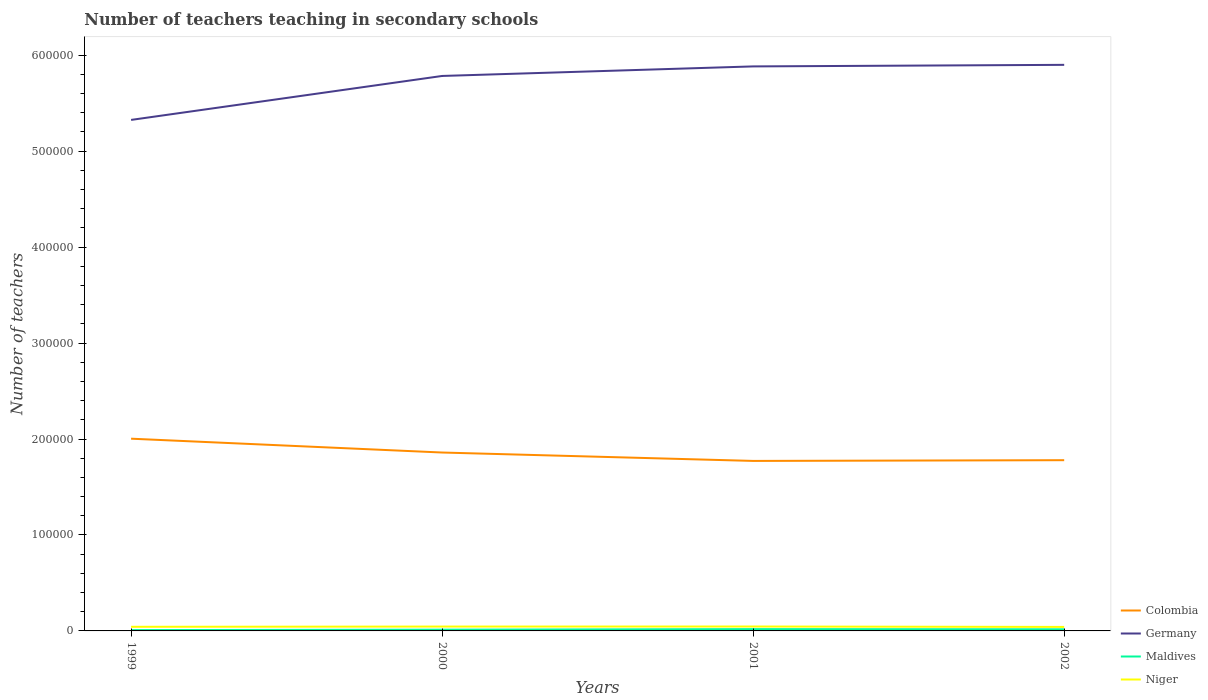Across all years, what is the maximum number of teachers teaching in secondary schools in Colombia?
Your answer should be compact. 1.77e+05. In which year was the number of teachers teaching in secondary schools in Germany maximum?
Keep it short and to the point. 1999. What is the total number of teachers teaching in secondary schools in Maldives in the graph?
Your response must be concise. -574. What is the difference between the highest and the second highest number of teachers teaching in secondary schools in Maldives?
Provide a short and direct response. 1010. What is the difference between the highest and the lowest number of teachers teaching in secondary schools in Maldives?
Your answer should be very brief. 2. Is the number of teachers teaching in secondary schools in Maldives strictly greater than the number of teachers teaching in secondary schools in Colombia over the years?
Offer a very short reply. Yes. Are the values on the major ticks of Y-axis written in scientific E-notation?
Your answer should be compact. No. Does the graph contain grids?
Your response must be concise. No. How are the legend labels stacked?
Your answer should be compact. Vertical. What is the title of the graph?
Offer a very short reply. Number of teachers teaching in secondary schools. What is the label or title of the Y-axis?
Offer a very short reply. Number of teachers. What is the Number of teachers in Colombia in 1999?
Your answer should be very brief. 2.00e+05. What is the Number of teachers in Germany in 1999?
Offer a terse response. 5.33e+05. What is the Number of teachers of Maldives in 1999?
Ensure brevity in your answer.  874. What is the Number of teachers in Niger in 1999?
Provide a short and direct response. 4303. What is the Number of teachers of Colombia in 2000?
Give a very brief answer. 1.86e+05. What is the Number of teachers of Germany in 2000?
Your answer should be compact. 5.78e+05. What is the Number of teachers in Maldives in 2000?
Your answer should be very brief. 1310. What is the Number of teachers of Niger in 2000?
Your answer should be very brief. 4537. What is the Number of teachers in Colombia in 2001?
Provide a short and direct response. 1.77e+05. What is the Number of teachers in Germany in 2001?
Offer a terse response. 5.88e+05. What is the Number of teachers in Maldives in 2001?
Ensure brevity in your answer.  1884. What is the Number of teachers of Niger in 2001?
Offer a very short reply. 4589. What is the Number of teachers of Colombia in 2002?
Offer a very short reply. 1.78e+05. What is the Number of teachers in Germany in 2002?
Provide a short and direct response. 5.90e+05. What is the Number of teachers of Maldives in 2002?
Keep it short and to the point. 1691. What is the Number of teachers of Niger in 2002?
Provide a short and direct response. 4165. Across all years, what is the maximum Number of teachers in Colombia?
Keep it short and to the point. 2.00e+05. Across all years, what is the maximum Number of teachers in Germany?
Give a very brief answer. 5.90e+05. Across all years, what is the maximum Number of teachers of Maldives?
Make the answer very short. 1884. Across all years, what is the maximum Number of teachers in Niger?
Your response must be concise. 4589. Across all years, what is the minimum Number of teachers in Colombia?
Provide a succinct answer. 1.77e+05. Across all years, what is the minimum Number of teachers in Germany?
Give a very brief answer. 5.33e+05. Across all years, what is the minimum Number of teachers in Maldives?
Provide a short and direct response. 874. Across all years, what is the minimum Number of teachers in Niger?
Your answer should be compact. 4165. What is the total Number of teachers of Colombia in the graph?
Ensure brevity in your answer.  7.41e+05. What is the total Number of teachers of Germany in the graph?
Offer a terse response. 2.29e+06. What is the total Number of teachers of Maldives in the graph?
Provide a succinct answer. 5759. What is the total Number of teachers in Niger in the graph?
Your answer should be compact. 1.76e+04. What is the difference between the Number of teachers in Colombia in 1999 and that in 2000?
Make the answer very short. 1.44e+04. What is the difference between the Number of teachers in Germany in 1999 and that in 2000?
Keep it short and to the point. -4.58e+04. What is the difference between the Number of teachers of Maldives in 1999 and that in 2000?
Provide a succinct answer. -436. What is the difference between the Number of teachers in Niger in 1999 and that in 2000?
Make the answer very short. -234. What is the difference between the Number of teachers of Colombia in 1999 and that in 2001?
Provide a succinct answer. 2.32e+04. What is the difference between the Number of teachers in Germany in 1999 and that in 2001?
Provide a short and direct response. -5.58e+04. What is the difference between the Number of teachers in Maldives in 1999 and that in 2001?
Give a very brief answer. -1010. What is the difference between the Number of teachers in Niger in 1999 and that in 2001?
Make the answer very short. -286. What is the difference between the Number of teachers in Colombia in 1999 and that in 2002?
Make the answer very short. 2.24e+04. What is the difference between the Number of teachers of Germany in 1999 and that in 2002?
Provide a short and direct response. -5.74e+04. What is the difference between the Number of teachers of Maldives in 1999 and that in 2002?
Provide a short and direct response. -817. What is the difference between the Number of teachers in Niger in 1999 and that in 2002?
Provide a succinct answer. 138. What is the difference between the Number of teachers of Colombia in 2000 and that in 2001?
Provide a succinct answer. 8747. What is the difference between the Number of teachers of Germany in 2000 and that in 2001?
Make the answer very short. -9953. What is the difference between the Number of teachers of Maldives in 2000 and that in 2001?
Your response must be concise. -574. What is the difference between the Number of teachers of Niger in 2000 and that in 2001?
Offer a terse response. -52. What is the difference between the Number of teachers in Colombia in 2000 and that in 2002?
Offer a very short reply. 7984. What is the difference between the Number of teachers in Germany in 2000 and that in 2002?
Provide a short and direct response. -1.16e+04. What is the difference between the Number of teachers of Maldives in 2000 and that in 2002?
Your answer should be compact. -381. What is the difference between the Number of teachers in Niger in 2000 and that in 2002?
Keep it short and to the point. 372. What is the difference between the Number of teachers of Colombia in 2001 and that in 2002?
Give a very brief answer. -763. What is the difference between the Number of teachers in Germany in 2001 and that in 2002?
Your answer should be very brief. -1636. What is the difference between the Number of teachers of Maldives in 2001 and that in 2002?
Offer a very short reply. 193. What is the difference between the Number of teachers of Niger in 2001 and that in 2002?
Ensure brevity in your answer.  424. What is the difference between the Number of teachers of Colombia in 1999 and the Number of teachers of Germany in 2000?
Provide a short and direct response. -3.78e+05. What is the difference between the Number of teachers in Colombia in 1999 and the Number of teachers in Maldives in 2000?
Ensure brevity in your answer.  1.99e+05. What is the difference between the Number of teachers of Colombia in 1999 and the Number of teachers of Niger in 2000?
Give a very brief answer. 1.96e+05. What is the difference between the Number of teachers of Germany in 1999 and the Number of teachers of Maldives in 2000?
Offer a very short reply. 5.31e+05. What is the difference between the Number of teachers in Germany in 1999 and the Number of teachers in Niger in 2000?
Ensure brevity in your answer.  5.28e+05. What is the difference between the Number of teachers of Maldives in 1999 and the Number of teachers of Niger in 2000?
Offer a very short reply. -3663. What is the difference between the Number of teachers of Colombia in 1999 and the Number of teachers of Germany in 2001?
Your answer should be compact. -3.88e+05. What is the difference between the Number of teachers of Colombia in 1999 and the Number of teachers of Maldives in 2001?
Offer a very short reply. 1.98e+05. What is the difference between the Number of teachers in Colombia in 1999 and the Number of teachers in Niger in 2001?
Give a very brief answer. 1.96e+05. What is the difference between the Number of teachers of Germany in 1999 and the Number of teachers of Maldives in 2001?
Provide a succinct answer. 5.31e+05. What is the difference between the Number of teachers of Germany in 1999 and the Number of teachers of Niger in 2001?
Your response must be concise. 5.28e+05. What is the difference between the Number of teachers in Maldives in 1999 and the Number of teachers in Niger in 2001?
Ensure brevity in your answer.  -3715. What is the difference between the Number of teachers in Colombia in 1999 and the Number of teachers in Germany in 2002?
Offer a terse response. -3.90e+05. What is the difference between the Number of teachers in Colombia in 1999 and the Number of teachers in Maldives in 2002?
Your response must be concise. 1.99e+05. What is the difference between the Number of teachers in Colombia in 1999 and the Number of teachers in Niger in 2002?
Give a very brief answer. 1.96e+05. What is the difference between the Number of teachers of Germany in 1999 and the Number of teachers of Maldives in 2002?
Make the answer very short. 5.31e+05. What is the difference between the Number of teachers of Germany in 1999 and the Number of teachers of Niger in 2002?
Your answer should be compact. 5.28e+05. What is the difference between the Number of teachers of Maldives in 1999 and the Number of teachers of Niger in 2002?
Provide a short and direct response. -3291. What is the difference between the Number of teachers of Colombia in 2000 and the Number of teachers of Germany in 2001?
Your response must be concise. -4.02e+05. What is the difference between the Number of teachers of Colombia in 2000 and the Number of teachers of Maldives in 2001?
Offer a very short reply. 1.84e+05. What is the difference between the Number of teachers in Colombia in 2000 and the Number of teachers in Niger in 2001?
Make the answer very short. 1.81e+05. What is the difference between the Number of teachers in Germany in 2000 and the Number of teachers in Maldives in 2001?
Your response must be concise. 5.76e+05. What is the difference between the Number of teachers of Germany in 2000 and the Number of teachers of Niger in 2001?
Your answer should be compact. 5.74e+05. What is the difference between the Number of teachers of Maldives in 2000 and the Number of teachers of Niger in 2001?
Keep it short and to the point. -3279. What is the difference between the Number of teachers of Colombia in 2000 and the Number of teachers of Germany in 2002?
Give a very brief answer. -4.04e+05. What is the difference between the Number of teachers in Colombia in 2000 and the Number of teachers in Maldives in 2002?
Your answer should be compact. 1.84e+05. What is the difference between the Number of teachers in Colombia in 2000 and the Number of teachers in Niger in 2002?
Ensure brevity in your answer.  1.82e+05. What is the difference between the Number of teachers in Germany in 2000 and the Number of teachers in Maldives in 2002?
Your answer should be very brief. 5.77e+05. What is the difference between the Number of teachers of Germany in 2000 and the Number of teachers of Niger in 2002?
Provide a short and direct response. 5.74e+05. What is the difference between the Number of teachers of Maldives in 2000 and the Number of teachers of Niger in 2002?
Your answer should be compact. -2855. What is the difference between the Number of teachers of Colombia in 2001 and the Number of teachers of Germany in 2002?
Your answer should be compact. -4.13e+05. What is the difference between the Number of teachers of Colombia in 2001 and the Number of teachers of Maldives in 2002?
Make the answer very short. 1.75e+05. What is the difference between the Number of teachers in Colombia in 2001 and the Number of teachers in Niger in 2002?
Give a very brief answer. 1.73e+05. What is the difference between the Number of teachers of Germany in 2001 and the Number of teachers of Maldives in 2002?
Your answer should be very brief. 5.87e+05. What is the difference between the Number of teachers in Germany in 2001 and the Number of teachers in Niger in 2002?
Keep it short and to the point. 5.84e+05. What is the difference between the Number of teachers in Maldives in 2001 and the Number of teachers in Niger in 2002?
Offer a very short reply. -2281. What is the average Number of teachers in Colombia per year?
Offer a very short reply. 1.85e+05. What is the average Number of teachers of Germany per year?
Your response must be concise. 5.72e+05. What is the average Number of teachers in Maldives per year?
Your answer should be compact. 1439.75. What is the average Number of teachers in Niger per year?
Your response must be concise. 4398.5. In the year 1999, what is the difference between the Number of teachers of Colombia and Number of teachers of Germany?
Offer a very short reply. -3.32e+05. In the year 1999, what is the difference between the Number of teachers of Colombia and Number of teachers of Maldives?
Your response must be concise. 1.99e+05. In the year 1999, what is the difference between the Number of teachers in Colombia and Number of teachers in Niger?
Give a very brief answer. 1.96e+05. In the year 1999, what is the difference between the Number of teachers of Germany and Number of teachers of Maldives?
Offer a terse response. 5.32e+05. In the year 1999, what is the difference between the Number of teachers of Germany and Number of teachers of Niger?
Keep it short and to the point. 5.28e+05. In the year 1999, what is the difference between the Number of teachers in Maldives and Number of teachers in Niger?
Ensure brevity in your answer.  -3429. In the year 2000, what is the difference between the Number of teachers of Colombia and Number of teachers of Germany?
Your answer should be very brief. -3.92e+05. In the year 2000, what is the difference between the Number of teachers in Colombia and Number of teachers in Maldives?
Provide a short and direct response. 1.85e+05. In the year 2000, what is the difference between the Number of teachers of Colombia and Number of teachers of Niger?
Ensure brevity in your answer.  1.81e+05. In the year 2000, what is the difference between the Number of teachers in Germany and Number of teachers in Maldives?
Make the answer very short. 5.77e+05. In the year 2000, what is the difference between the Number of teachers in Germany and Number of teachers in Niger?
Keep it short and to the point. 5.74e+05. In the year 2000, what is the difference between the Number of teachers of Maldives and Number of teachers of Niger?
Ensure brevity in your answer.  -3227. In the year 2001, what is the difference between the Number of teachers of Colombia and Number of teachers of Germany?
Your answer should be very brief. -4.11e+05. In the year 2001, what is the difference between the Number of teachers of Colombia and Number of teachers of Maldives?
Your answer should be very brief. 1.75e+05. In the year 2001, what is the difference between the Number of teachers in Colombia and Number of teachers in Niger?
Provide a succinct answer. 1.73e+05. In the year 2001, what is the difference between the Number of teachers in Germany and Number of teachers in Maldives?
Your answer should be very brief. 5.86e+05. In the year 2001, what is the difference between the Number of teachers in Germany and Number of teachers in Niger?
Your answer should be very brief. 5.84e+05. In the year 2001, what is the difference between the Number of teachers in Maldives and Number of teachers in Niger?
Offer a terse response. -2705. In the year 2002, what is the difference between the Number of teachers in Colombia and Number of teachers in Germany?
Offer a very short reply. -4.12e+05. In the year 2002, what is the difference between the Number of teachers of Colombia and Number of teachers of Maldives?
Your answer should be compact. 1.76e+05. In the year 2002, what is the difference between the Number of teachers in Colombia and Number of teachers in Niger?
Keep it short and to the point. 1.74e+05. In the year 2002, what is the difference between the Number of teachers in Germany and Number of teachers in Maldives?
Keep it short and to the point. 5.88e+05. In the year 2002, what is the difference between the Number of teachers of Germany and Number of teachers of Niger?
Keep it short and to the point. 5.86e+05. In the year 2002, what is the difference between the Number of teachers in Maldives and Number of teachers in Niger?
Provide a short and direct response. -2474. What is the ratio of the Number of teachers in Colombia in 1999 to that in 2000?
Give a very brief answer. 1.08. What is the ratio of the Number of teachers in Germany in 1999 to that in 2000?
Provide a succinct answer. 0.92. What is the ratio of the Number of teachers of Maldives in 1999 to that in 2000?
Keep it short and to the point. 0.67. What is the ratio of the Number of teachers in Niger in 1999 to that in 2000?
Ensure brevity in your answer.  0.95. What is the ratio of the Number of teachers of Colombia in 1999 to that in 2001?
Make the answer very short. 1.13. What is the ratio of the Number of teachers of Germany in 1999 to that in 2001?
Ensure brevity in your answer.  0.91. What is the ratio of the Number of teachers of Maldives in 1999 to that in 2001?
Keep it short and to the point. 0.46. What is the ratio of the Number of teachers in Niger in 1999 to that in 2001?
Your answer should be compact. 0.94. What is the ratio of the Number of teachers in Colombia in 1999 to that in 2002?
Give a very brief answer. 1.13. What is the ratio of the Number of teachers in Germany in 1999 to that in 2002?
Offer a terse response. 0.9. What is the ratio of the Number of teachers of Maldives in 1999 to that in 2002?
Your response must be concise. 0.52. What is the ratio of the Number of teachers in Niger in 1999 to that in 2002?
Provide a succinct answer. 1.03. What is the ratio of the Number of teachers of Colombia in 2000 to that in 2001?
Offer a very short reply. 1.05. What is the ratio of the Number of teachers in Germany in 2000 to that in 2001?
Provide a succinct answer. 0.98. What is the ratio of the Number of teachers in Maldives in 2000 to that in 2001?
Provide a succinct answer. 0.7. What is the ratio of the Number of teachers in Niger in 2000 to that in 2001?
Your response must be concise. 0.99. What is the ratio of the Number of teachers of Colombia in 2000 to that in 2002?
Keep it short and to the point. 1.04. What is the ratio of the Number of teachers of Germany in 2000 to that in 2002?
Ensure brevity in your answer.  0.98. What is the ratio of the Number of teachers of Maldives in 2000 to that in 2002?
Ensure brevity in your answer.  0.77. What is the ratio of the Number of teachers in Niger in 2000 to that in 2002?
Your answer should be compact. 1.09. What is the ratio of the Number of teachers in Germany in 2001 to that in 2002?
Offer a terse response. 1. What is the ratio of the Number of teachers of Maldives in 2001 to that in 2002?
Offer a terse response. 1.11. What is the ratio of the Number of teachers in Niger in 2001 to that in 2002?
Provide a short and direct response. 1.1. What is the difference between the highest and the second highest Number of teachers in Colombia?
Make the answer very short. 1.44e+04. What is the difference between the highest and the second highest Number of teachers in Germany?
Your response must be concise. 1636. What is the difference between the highest and the second highest Number of teachers in Maldives?
Make the answer very short. 193. What is the difference between the highest and the second highest Number of teachers in Niger?
Your response must be concise. 52. What is the difference between the highest and the lowest Number of teachers in Colombia?
Make the answer very short. 2.32e+04. What is the difference between the highest and the lowest Number of teachers of Germany?
Provide a short and direct response. 5.74e+04. What is the difference between the highest and the lowest Number of teachers of Maldives?
Offer a terse response. 1010. What is the difference between the highest and the lowest Number of teachers of Niger?
Give a very brief answer. 424. 